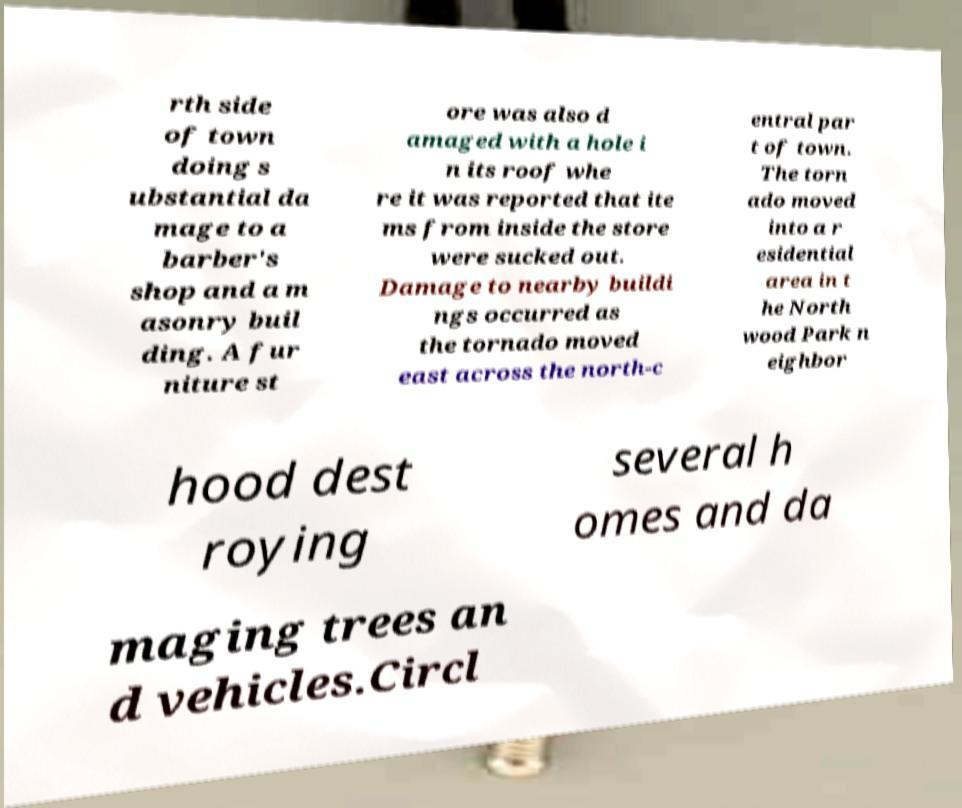Can you accurately transcribe the text from the provided image for me? rth side of town doing s ubstantial da mage to a barber's shop and a m asonry buil ding. A fur niture st ore was also d amaged with a hole i n its roof whe re it was reported that ite ms from inside the store were sucked out. Damage to nearby buildi ngs occurred as the tornado moved east across the north-c entral par t of town. The torn ado moved into a r esidential area in t he North wood Park n eighbor hood dest roying several h omes and da maging trees an d vehicles.Circl 